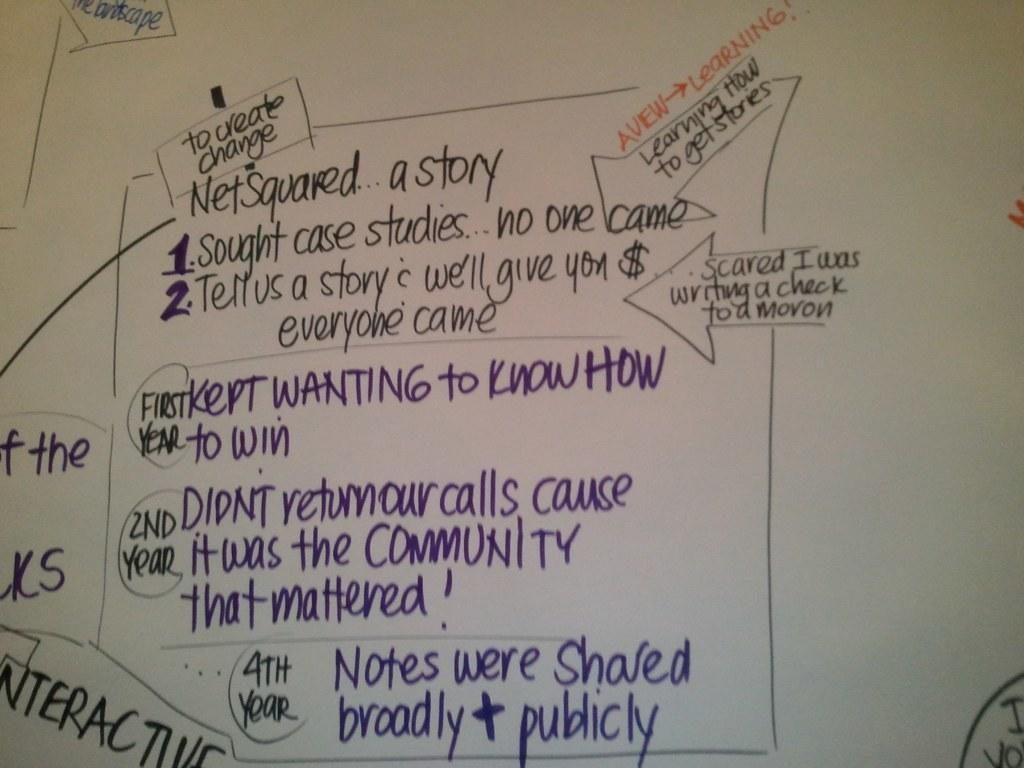<image>
Offer a succinct explanation of the picture presented. White board which says "Net Squared" on it. 